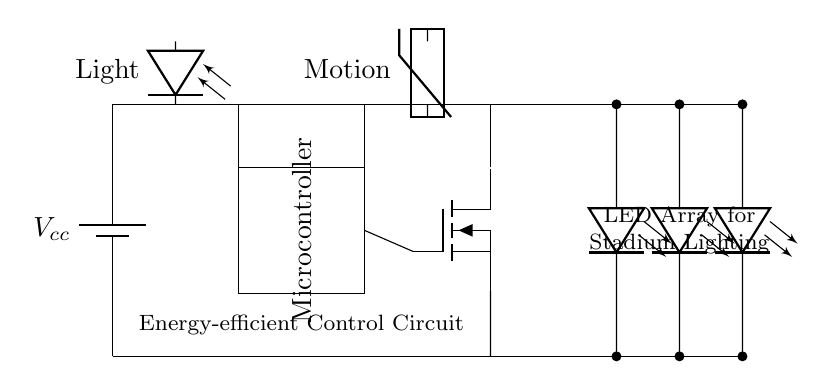What is the type of sensor used for detecting light? The circuit includes a photodiode labeled "Light," which is typically used for measuring light levels.
Answer: Photodiode What component controls the LED array? The MOSFET is used as a switch for controlling the LED array based on input signals from the microcontroller.
Answer: MOSFET What is the purpose of the microcontroller in this circuit? The microcontroller processes signals from the light and motion sensors to control the functioning of the LEDs, allowing for energy-efficient lighting management.
Answer: Control LED operation Which components are responsible for detecting motion? A thermistor is used in this circuit to detect motion, as indicated by the label "Motion."
Answer: Thermistor What can be inferred about the power supply voltage? The voltage label indicates a direct power supply of "Vcc," suggesting it provides necessary voltage to the circuit; the exact voltage value isn't specified but can be assumed suitable for operation.
Answer: Vcc How many LEDs are featured in the array? There are three LED units represented in the diagram, connected in a series arrangement for providing lighting in the stadium.
Answer: Three What is the overall function of this circuit? The circuit is designed for energy-efficient control of LED lighting in stadiums, responding dynamically to environmental inputs such as light and motion.
Answer: Lighting control 